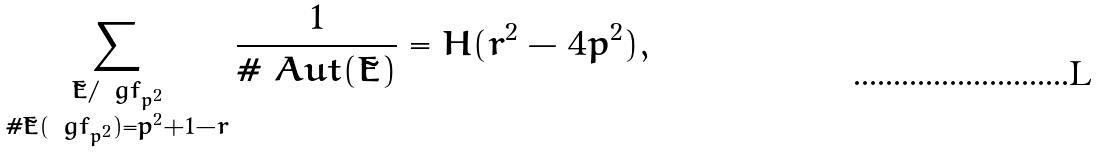<formula> <loc_0><loc_0><loc_500><loc_500>\sum _ { \substack { \tilde { E } / \ g f _ { p ^ { 2 } } \\ \# \tilde { E } ( \ g f _ { p ^ { 2 } } ) = p ^ { 2 } + 1 - r } } \frac { 1 } { \# \ A u t ( \tilde { E } ) } = H ( r ^ { 2 } - 4 p ^ { 2 } ) ,</formula> 